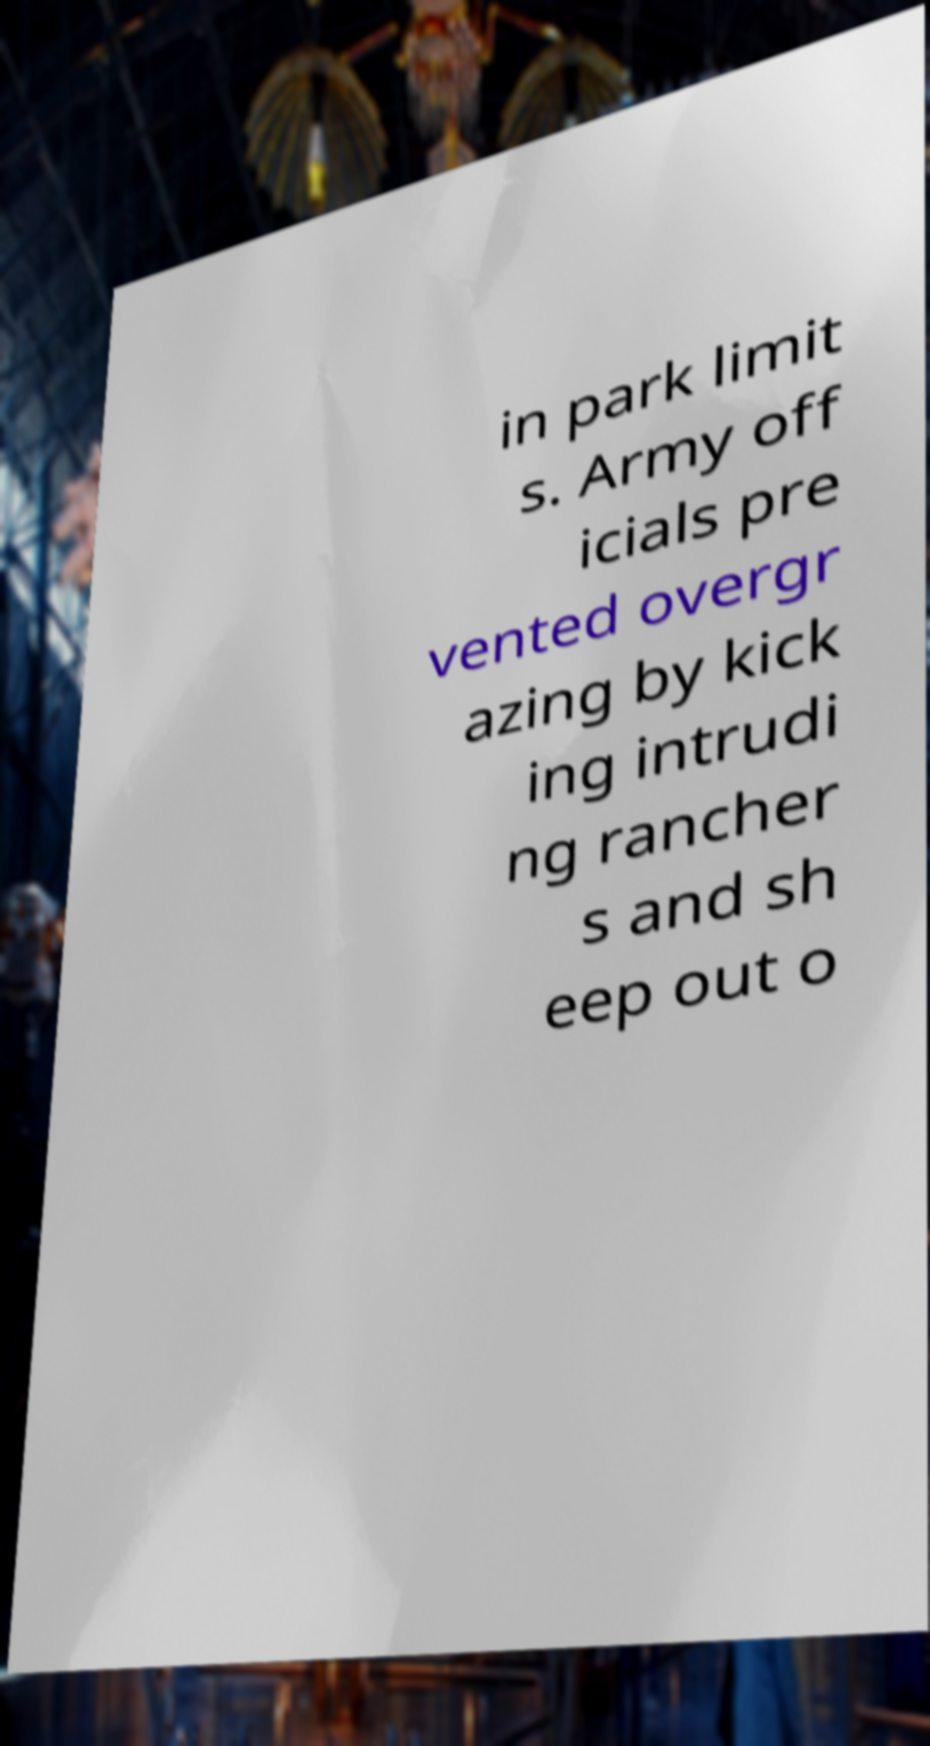Could you assist in decoding the text presented in this image and type it out clearly? in park limit s. Army off icials pre vented overgr azing by kick ing intrudi ng rancher s and sh eep out o 